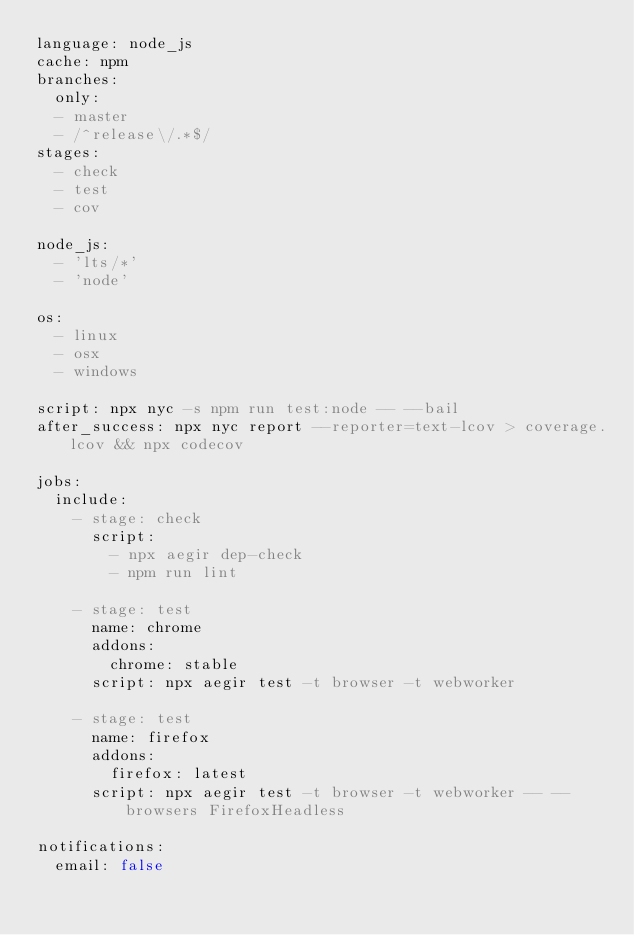<code> <loc_0><loc_0><loc_500><loc_500><_YAML_>language: node_js
cache: npm
branches:
  only:
  - master
  - /^release\/.*$/
stages:
  - check
  - test
  - cov

node_js:
  - 'lts/*'
  - 'node'

os:
  - linux
  - osx
  - windows

script: npx nyc -s npm run test:node -- --bail
after_success: npx nyc report --reporter=text-lcov > coverage.lcov && npx codecov

jobs:
  include:
    - stage: check
      script:
        - npx aegir dep-check
        - npm run lint

    - stage: test
      name: chrome
      addons:
        chrome: stable
      script: npx aegir test -t browser -t webworker

    - stage: test
      name: firefox
      addons:
        firefox: latest
      script: npx aegir test -t browser -t webworker -- --browsers FirefoxHeadless

notifications:
  email: false
</code> 